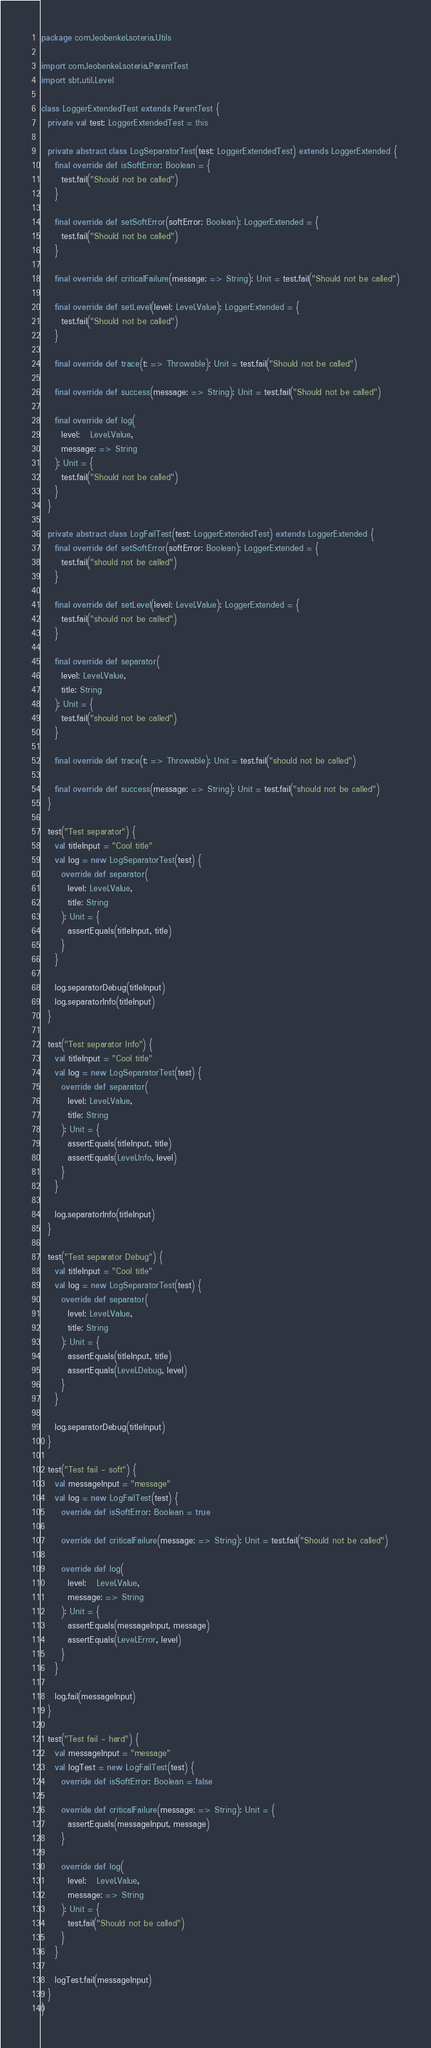Convert code to text. <code><loc_0><loc_0><loc_500><loc_500><_Scala_>package com.leobenkel.soteria.Utils

import com.leobenkel.soteria.ParentTest
import sbt.util.Level

class LoggerExtendedTest extends ParentTest {
  private val test: LoggerExtendedTest = this

  private abstract class LogSeparatorTest(test: LoggerExtendedTest) extends LoggerExtended {
    final override def isSoftError: Boolean = {
      test.fail("Should not be called")
    }

    final override def setSoftError(softError: Boolean): LoggerExtended = {
      test.fail("Should not be called")
    }

    final override def criticalFailure(message: => String): Unit = test.fail("Should not be called")

    final override def setLevel(level: Level.Value): LoggerExtended = {
      test.fail("Should not be called")
    }

    final override def trace(t: => Throwable): Unit = test.fail("Should not be called")

    final override def success(message: => String): Unit = test.fail("Should not be called")

    final override def log(
      level:   Level.Value,
      message: => String
    ): Unit = {
      test.fail("Should not be called")
    }
  }

  private abstract class LogFailTest(test: LoggerExtendedTest) extends LoggerExtended {
    final override def setSoftError(softError: Boolean): LoggerExtended = {
      test.fail("should not be called")
    }

    final override def setLevel(level: Level.Value): LoggerExtended = {
      test.fail("should not be called")
    }

    final override def separator(
      level: Level.Value,
      title: String
    ): Unit = {
      test.fail("should not be called")
    }

    final override def trace(t: => Throwable): Unit = test.fail("should not be called")

    final override def success(message: => String): Unit = test.fail("should not be called")
  }

  test("Test separator") {
    val titleInput = "Cool title"
    val log = new LogSeparatorTest(test) {
      override def separator(
        level: Level.Value,
        title: String
      ): Unit = {
        assertEquals(titleInput, title)
      }
    }

    log.separatorDebug(titleInput)
    log.separatorInfo(titleInput)
  }

  test("Test separator Info") {
    val titleInput = "Cool title"
    val log = new LogSeparatorTest(test) {
      override def separator(
        level: Level.Value,
        title: String
      ): Unit = {
        assertEquals(titleInput, title)
        assertEquals(Level.Info, level)
      }
    }

    log.separatorInfo(titleInput)
  }

  test("Test separator Debug") {
    val titleInput = "Cool title"
    val log = new LogSeparatorTest(test) {
      override def separator(
        level: Level.Value,
        title: String
      ): Unit = {
        assertEquals(titleInput, title)
        assertEquals(Level.Debug, level)
      }
    }

    log.separatorDebug(titleInput)
  }

  test("Test fail - soft") {
    val messageInput = "message"
    val log = new LogFailTest(test) {
      override def isSoftError: Boolean = true

      override def criticalFailure(message: => String): Unit = test.fail("Should not be called")

      override def log(
        level:   Level.Value,
        message: => String
      ): Unit = {
        assertEquals(messageInput, message)
        assertEquals(Level.Error, level)
      }
    }

    log.fail(messageInput)
  }

  test("Test fail - hard") {
    val messageInput = "message"
    val logTest = new LogFailTest(test) {
      override def isSoftError: Boolean = false

      override def criticalFailure(message: => String): Unit = {
        assertEquals(messageInput, message)
      }

      override def log(
        level:   Level.Value,
        message: => String
      ): Unit = {
        test.fail("Should not be called")
      }
    }

    logTest.fail(messageInput)
  }
}
</code> 